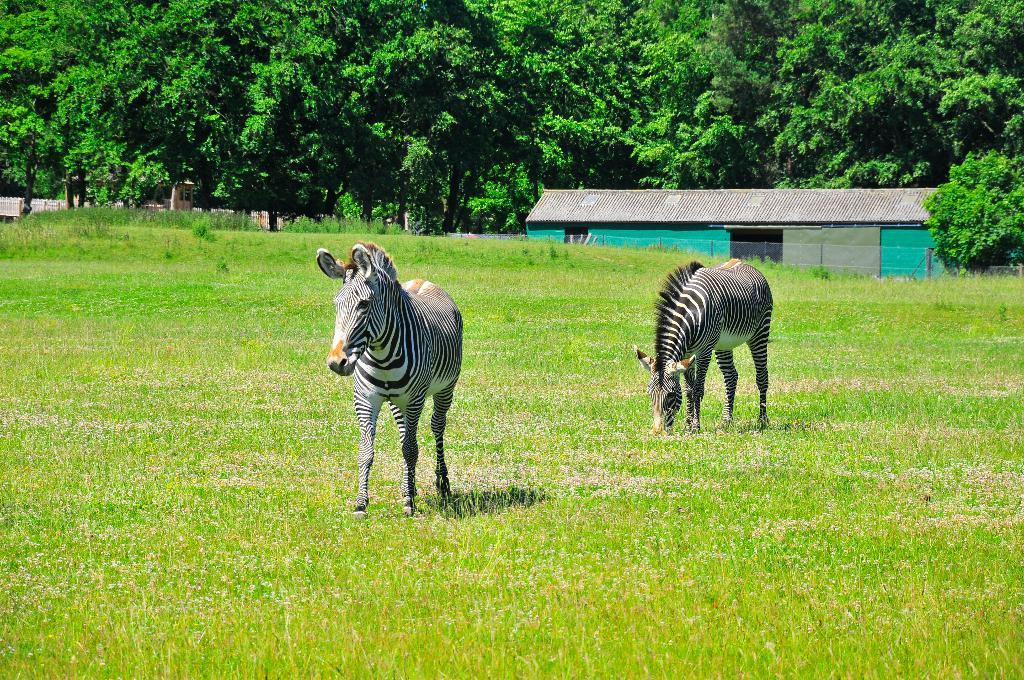What animals can be seen on the ground in the image? There are zebras on the ground in the image. What type of vegetation is present on the ground in the image? There is grass on the ground in the image. What can be seen in the background of the image? There is a building and trees in the background of the image. What type of machine is being used by the zebras in the image? There is no machine present in the image; the zebras are simply standing on the grass. 